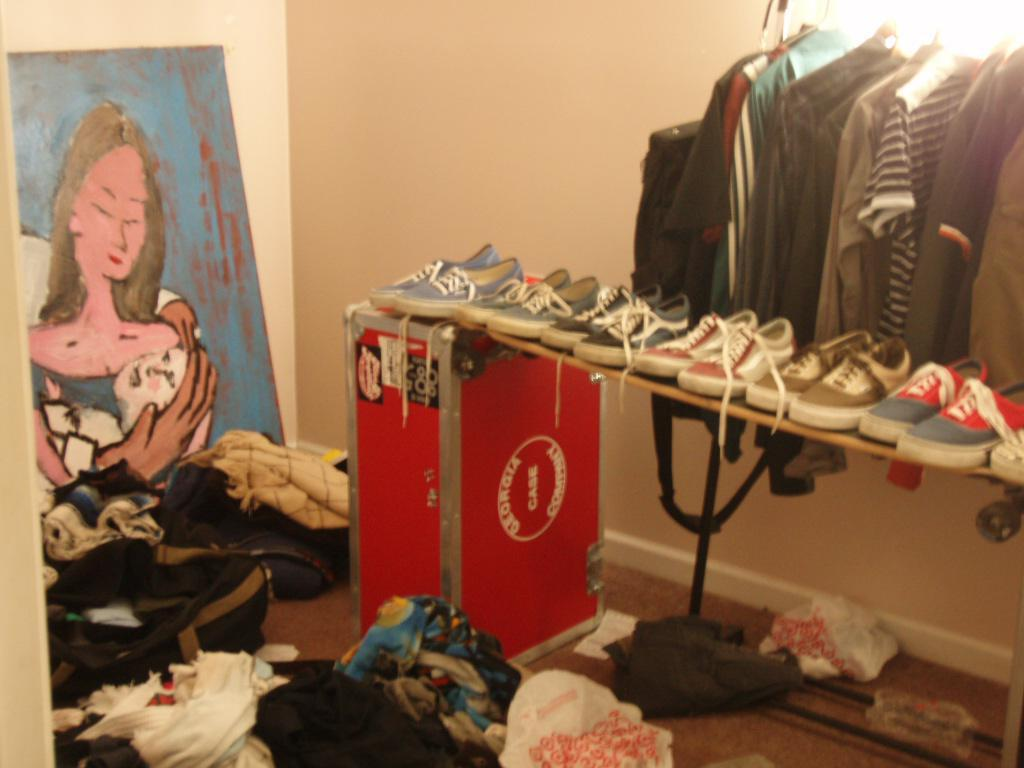What can be seen on the right side of the image? There are clothes arranged and a light on the right side of the image. What is the condition of the clothes on the floor in the image? There are clothes on the floor in the image. What is located at the left side of the image? There is a painting at the left side of the image. How does the fact of the painting affect the clothes on the floor? The fact of the painting does not affect the clothes on the floor, as they are separate elements in the image. What type of pain is being experienced by the clothes on the floor? There is no indication of pain being experienced by the clothes on the floor, as they are inanimate objects. 